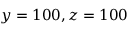<formula> <loc_0><loc_0><loc_500><loc_500>y = 1 0 0 z = 1 0 0</formula> 